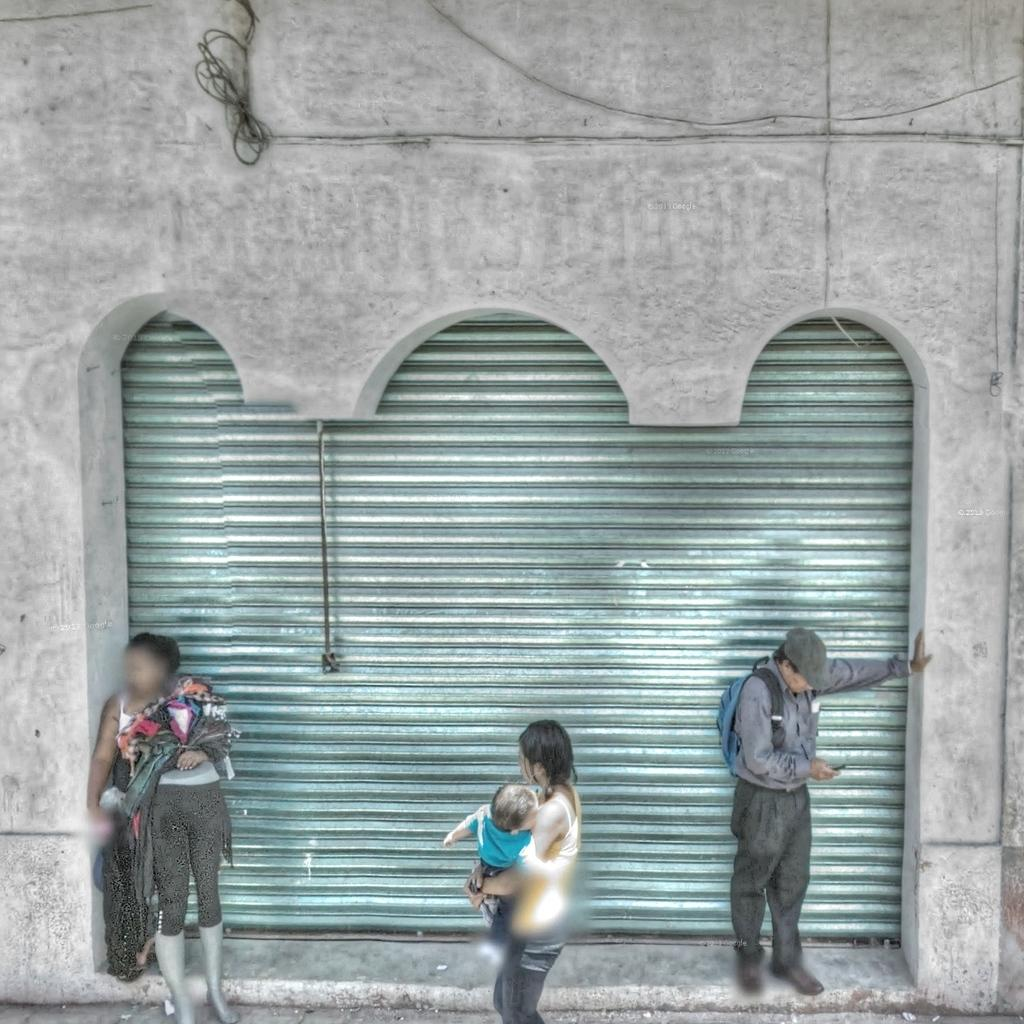How many people are in the image? There are three persons in the foreground of the image. What is located behind the persons? There is a shutter behind the persons. What type of objects can be seen in the image? Cables are visible in the image. What type of structure is present in the image? There is a wall in the image. What type of riddle can be seen written on the wall in the image? There is no riddle written on the wall in the image; it is a plain wall. What type of office furniture can be seen in the image? There is no office furniture present in the image. 